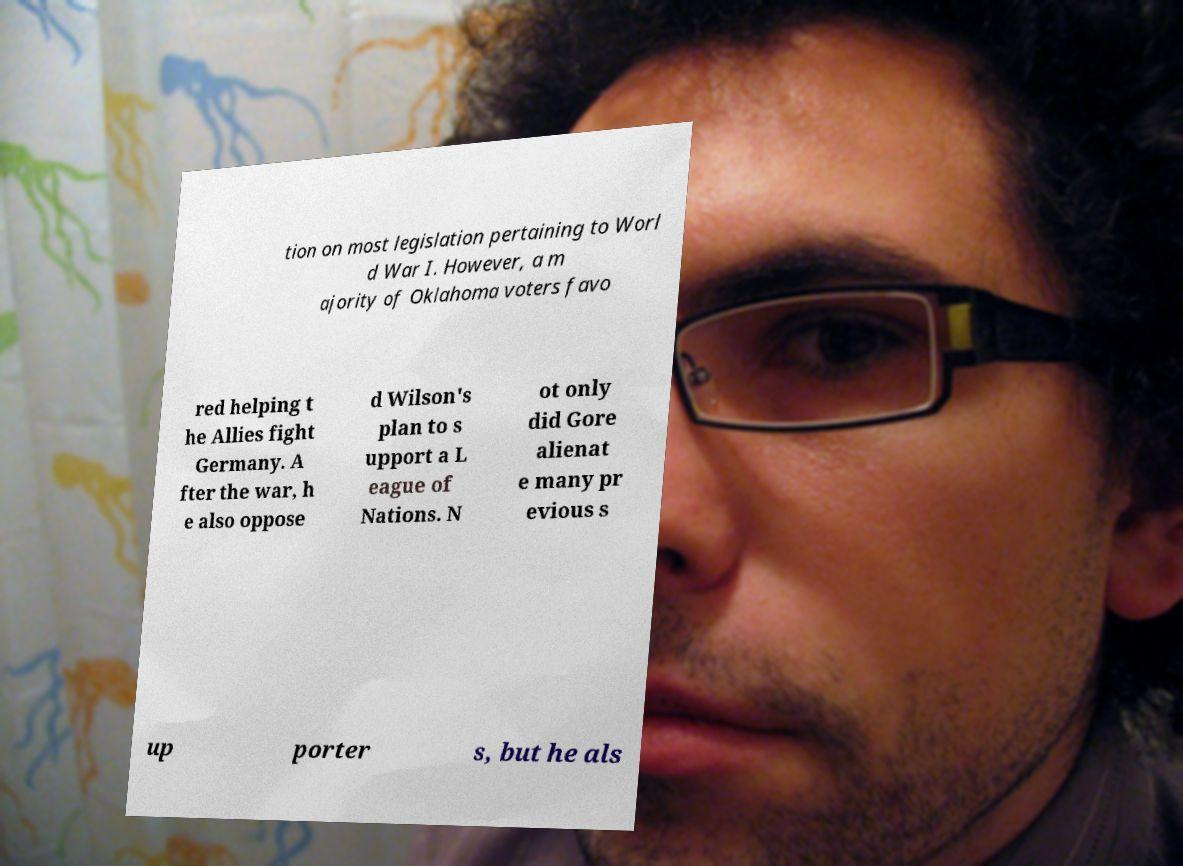For documentation purposes, I need the text within this image transcribed. Could you provide that? tion on most legislation pertaining to Worl d War I. However, a m ajority of Oklahoma voters favo red helping t he Allies fight Germany. A fter the war, h e also oppose d Wilson's plan to s upport a L eague of Nations. N ot only did Gore alienat e many pr evious s up porter s, but he als 